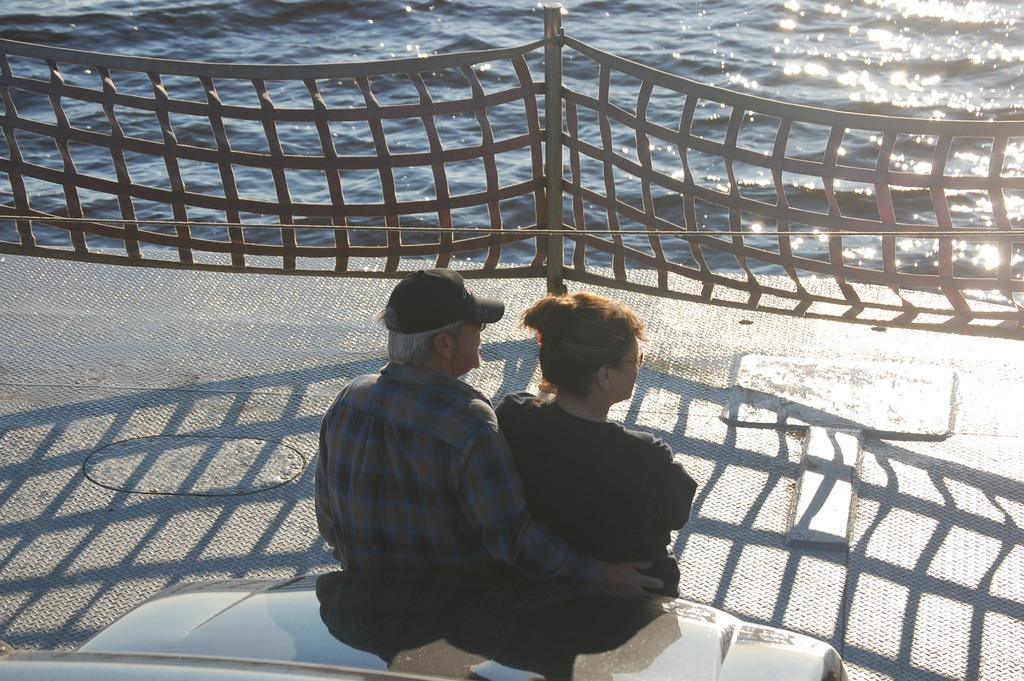How many people are present in the image? There are two people, a man and a woman, present in the image. What are the man and woman doing in the image? Both the man and woman are standing on the ground. What is located beside the man and woman? There is a car beside them. What type of structure can be seen in the image? There is a fence with a pole in the image. What natural feature is visible in the image? There is a water body in the image. What type of sand can be seen in the image? There is no sand present in the image. Is the woman's daughter visible in the image? The provided facts do not mention a daughter, so it cannot be determined if she is present in the image. 